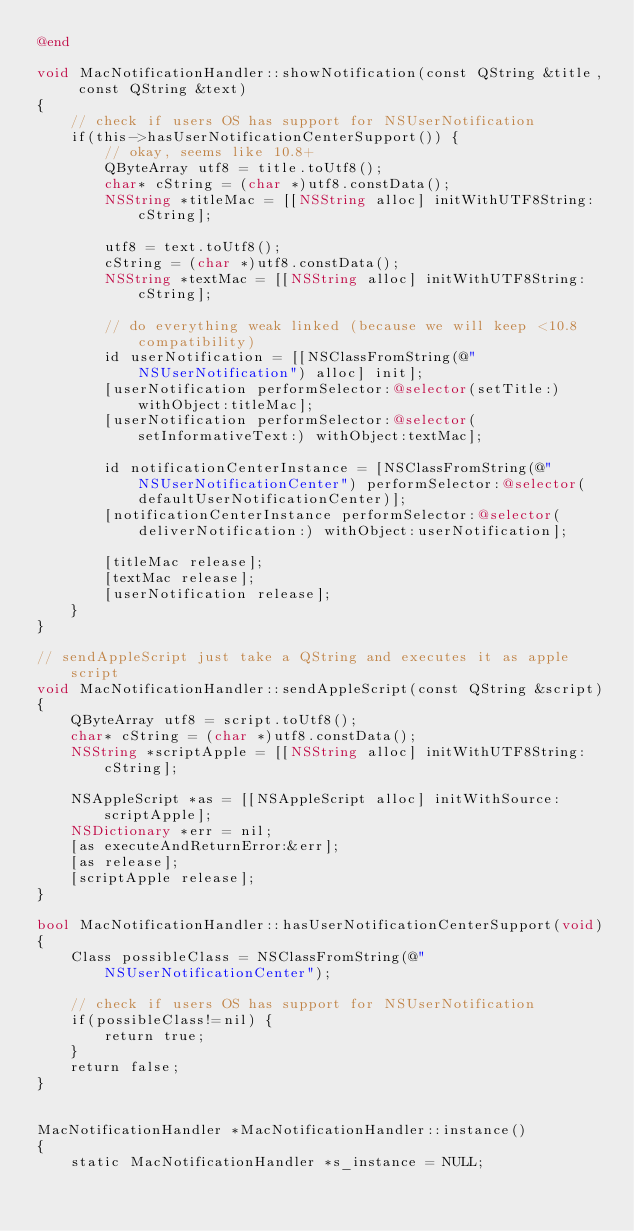Convert code to text. <code><loc_0><loc_0><loc_500><loc_500><_ObjectiveC_>@end

void MacNotificationHandler::showNotification(const QString &title, const QString &text)
{
    // check if users OS has support for NSUserNotification
    if(this->hasUserNotificationCenterSupport()) {
        // okay, seems like 10.8+
        QByteArray utf8 = title.toUtf8();
        char* cString = (char *)utf8.constData();
        NSString *titleMac = [[NSString alloc] initWithUTF8String:cString];

        utf8 = text.toUtf8();
        cString = (char *)utf8.constData();
        NSString *textMac = [[NSString alloc] initWithUTF8String:cString];

        // do everything weak linked (because we will keep <10.8 compatibility)
        id userNotification = [[NSClassFromString(@"NSUserNotification") alloc] init];
        [userNotification performSelector:@selector(setTitle:) withObject:titleMac];
        [userNotification performSelector:@selector(setInformativeText:) withObject:textMac];

        id notificationCenterInstance = [NSClassFromString(@"NSUserNotificationCenter") performSelector:@selector(defaultUserNotificationCenter)];
        [notificationCenterInstance performSelector:@selector(deliverNotification:) withObject:userNotification];

        [titleMac release];
        [textMac release];
        [userNotification release];
    }
}

// sendAppleScript just take a QString and executes it as apple script
void MacNotificationHandler::sendAppleScript(const QString &script)
{
    QByteArray utf8 = script.toUtf8();
    char* cString = (char *)utf8.constData();
    NSString *scriptApple = [[NSString alloc] initWithUTF8String:cString];

    NSAppleScript *as = [[NSAppleScript alloc] initWithSource:scriptApple];
    NSDictionary *err = nil;
    [as executeAndReturnError:&err];
    [as release];
    [scriptApple release];
}

bool MacNotificationHandler::hasUserNotificationCenterSupport(void)
{
    Class possibleClass = NSClassFromString(@"NSUserNotificationCenter");

    // check if users OS has support for NSUserNotification
    if(possibleClass!=nil) {
        return true;
    }
    return false;
}


MacNotificationHandler *MacNotificationHandler::instance()
{
    static MacNotificationHandler *s_instance = NULL;</code> 